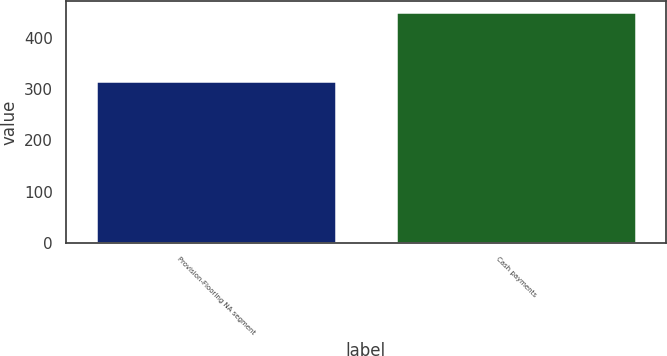<chart> <loc_0><loc_0><loc_500><loc_500><bar_chart><fcel>Provision-Flooring NA segment<fcel>Cash payments<nl><fcel>316<fcel>449<nl></chart> 